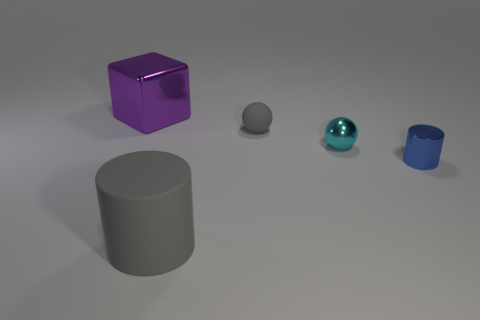Add 1 small cyan metal things. How many objects exist? 6 Subtract all cyan spheres. How many spheres are left? 1 Subtract 1 gray cylinders. How many objects are left? 4 Subtract all cubes. How many objects are left? 4 Subtract all yellow cylinders. Subtract all cyan blocks. How many cylinders are left? 2 Subtract all cyan metal things. Subtract all tiny gray spheres. How many objects are left? 3 Add 1 small blue metallic cylinders. How many small blue metallic cylinders are left? 2 Add 3 purple things. How many purple things exist? 4 